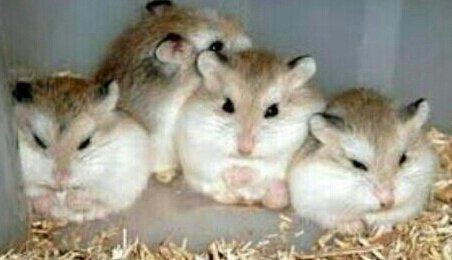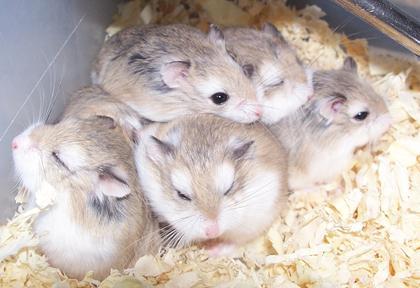The first image is the image on the left, the second image is the image on the right. Evaluate the accuracy of this statement regarding the images: "There are exactly 3 hamsters.". Is it true? Answer yes or no. No. The first image is the image on the left, the second image is the image on the right. For the images displayed, is the sentence "The right image contains at least two rodents." factually correct? Answer yes or no. Yes. 